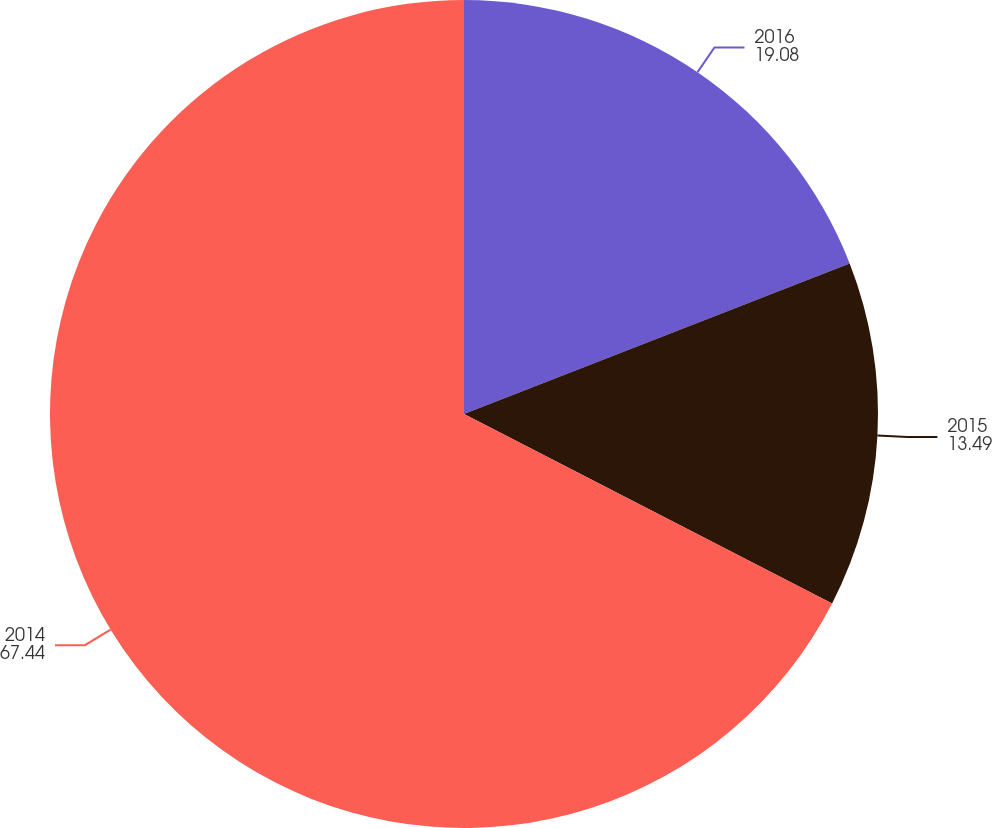Convert chart to OTSL. <chart><loc_0><loc_0><loc_500><loc_500><pie_chart><fcel>2016<fcel>2015<fcel>2014<nl><fcel>19.08%<fcel>13.49%<fcel>67.44%<nl></chart> 